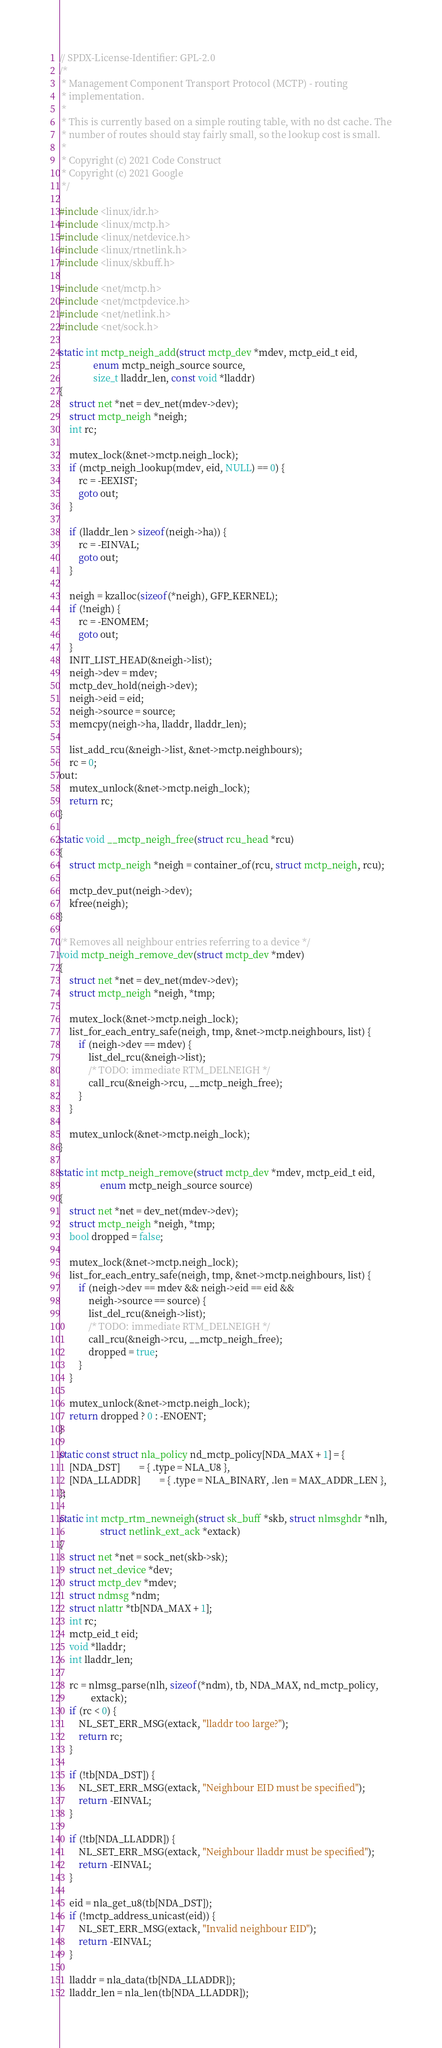Convert code to text. <code><loc_0><loc_0><loc_500><loc_500><_C_>// SPDX-License-Identifier: GPL-2.0
/*
 * Management Component Transport Protocol (MCTP) - routing
 * implementation.
 *
 * This is currently based on a simple routing table, with no dst cache. The
 * number of routes should stay fairly small, so the lookup cost is small.
 *
 * Copyright (c) 2021 Code Construct
 * Copyright (c) 2021 Google
 */

#include <linux/idr.h>
#include <linux/mctp.h>
#include <linux/netdevice.h>
#include <linux/rtnetlink.h>
#include <linux/skbuff.h>

#include <net/mctp.h>
#include <net/mctpdevice.h>
#include <net/netlink.h>
#include <net/sock.h>

static int mctp_neigh_add(struct mctp_dev *mdev, mctp_eid_t eid,
			  enum mctp_neigh_source source,
			  size_t lladdr_len, const void *lladdr)
{
	struct net *net = dev_net(mdev->dev);
	struct mctp_neigh *neigh;
	int rc;

	mutex_lock(&net->mctp.neigh_lock);
	if (mctp_neigh_lookup(mdev, eid, NULL) == 0) {
		rc = -EEXIST;
		goto out;
	}

	if (lladdr_len > sizeof(neigh->ha)) {
		rc = -EINVAL;
		goto out;
	}

	neigh = kzalloc(sizeof(*neigh), GFP_KERNEL);
	if (!neigh) {
		rc = -ENOMEM;
		goto out;
	}
	INIT_LIST_HEAD(&neigh->list);
	neigh->dev = mdev;
	mctp_dev_hold(neigh->dev);
	neigh->eid = eid;
	neigh->source = source;
	memcpy(neigh->ha, lladdr, lladdr_len);

	list_add_rcu(&neigh->list, &net->mctp.neighbours);
	rc = 0;
out:
	mutex_unlock(&net->mctp.neigh_lock);
	return rc;
}

static void __mctp_neigh_free(struct rcu_head *rcu)
{
	struct mctp_neigh *neigh = container_of(rcu, struct mctp_neigh, rcu);

	mctp_dev_put(neigh->dev);
	kfree(neigh);
}

/* Removes all neighbour entries referring to a device */
void mctp_neigh_remove_dev(struct mctp_dev *mdev)
{
	struct net *net = dev_net(mdev->dev);
	struct mctp_neigh *neigh, *tmp;

	mutex_lock(&net->mctp.neigh_lock);
	list_for_each_entry_safe(neigh, tmp, &net->mctp.neighbours, list) {
		if (neigh->dev == mdev) {
			list_del_rcu(&neigh->list);
			/* TODO: immediate RTM_DELNEIGH */
			call_rcu(&neigh->rcu, __mctp_neigh_free);
		}
	}

	mutex_unlock(&net->mctp.neigh_lock);
}

static int mctp_neigh_remove(struct mctp_dev *mdev, mctp_eid_t eid,
			     enum mctp_neigh_source source)
{
	struct net *net = dev_net(mdev->dev);
	struct mctp_neigh *neigh, *tmp;
	bool dropped = false;

	mutex_lock(&net->mctp.neigh_lock);
	list_for_each_entry_safe(neigh, tmp, &net->mctp.neighbours, list) {
		if (neigh->dev == mdev && neigh->eid == eid &&
		    neigh->source == source) {
			list_del_rcu(&neigh->list);
			/* TODO: immediate RTM_DELNEIGH */
			call_rcu(&neigh->rcu, __mctp_neigh_free);
			dropped = true;
		}
	}

	mutex_unlock(&net->mctp.neigh_lock);
	return dropped ? 0 : -ENOENT;
}

static const struct nla_policy nd_mctp_policy[NDA_MAX + 1] = {
	[NDA_DST]		= { .type = NLA_U8 },
	[NDA_LLADDR]		= { .type = NLA_BINARY, .len = MAX_ADDR_LEN },
};

static int mctp_rtm_newneigh(struct sk_buff *skb, struct nlmsghdr *nlh,
			     struct netlink_ext_ack *extack)
{
	struct net *net = sock_net(skb->sk);
	struct net_device *dev;
	struct mctp_dev *mdev;
	struct ndmsg *ndm;
	struct nlattr *tb[NDA_MAX + 1];
	int rc;
	mctp_eid_t eid;
	void *lladdr;
	int lladdr_len;

	rc = nlmsg_parse(nlh, sizeof(*ndm), tb, NDA_MAX, nd_mctp_policy,
			 extack);
	if (rc < 0) {
		NL_SET_ERR_MSG(extack, "lladdr too large?");
		return rc;
	}

	if (!tb[NDA_DST]) {
		NL_SET_ERR_MSG(extack, "Neighbour EID must be specified");
		return -EINVAL;
	}

	if (!tb[NDA_LLADDR]) {
		NL_SET_ERR_MSG(extack, "Neighbour lladdr must be specified");
		return -EINVAL;
	}

	eid = nla_get_u8(tb[NDA_DST]);
	if (!mctp_address_unicast(eid)) {
		NL_SET_ERR_MSG(extack, "Invalid neighbour EID");
		return -EINVAL;
	}

	lladdr = nla_data(tb[NDA_LLADDR]);
	lladdr_len = nla_len(tb[NDA_LLADDR]);
</code> 